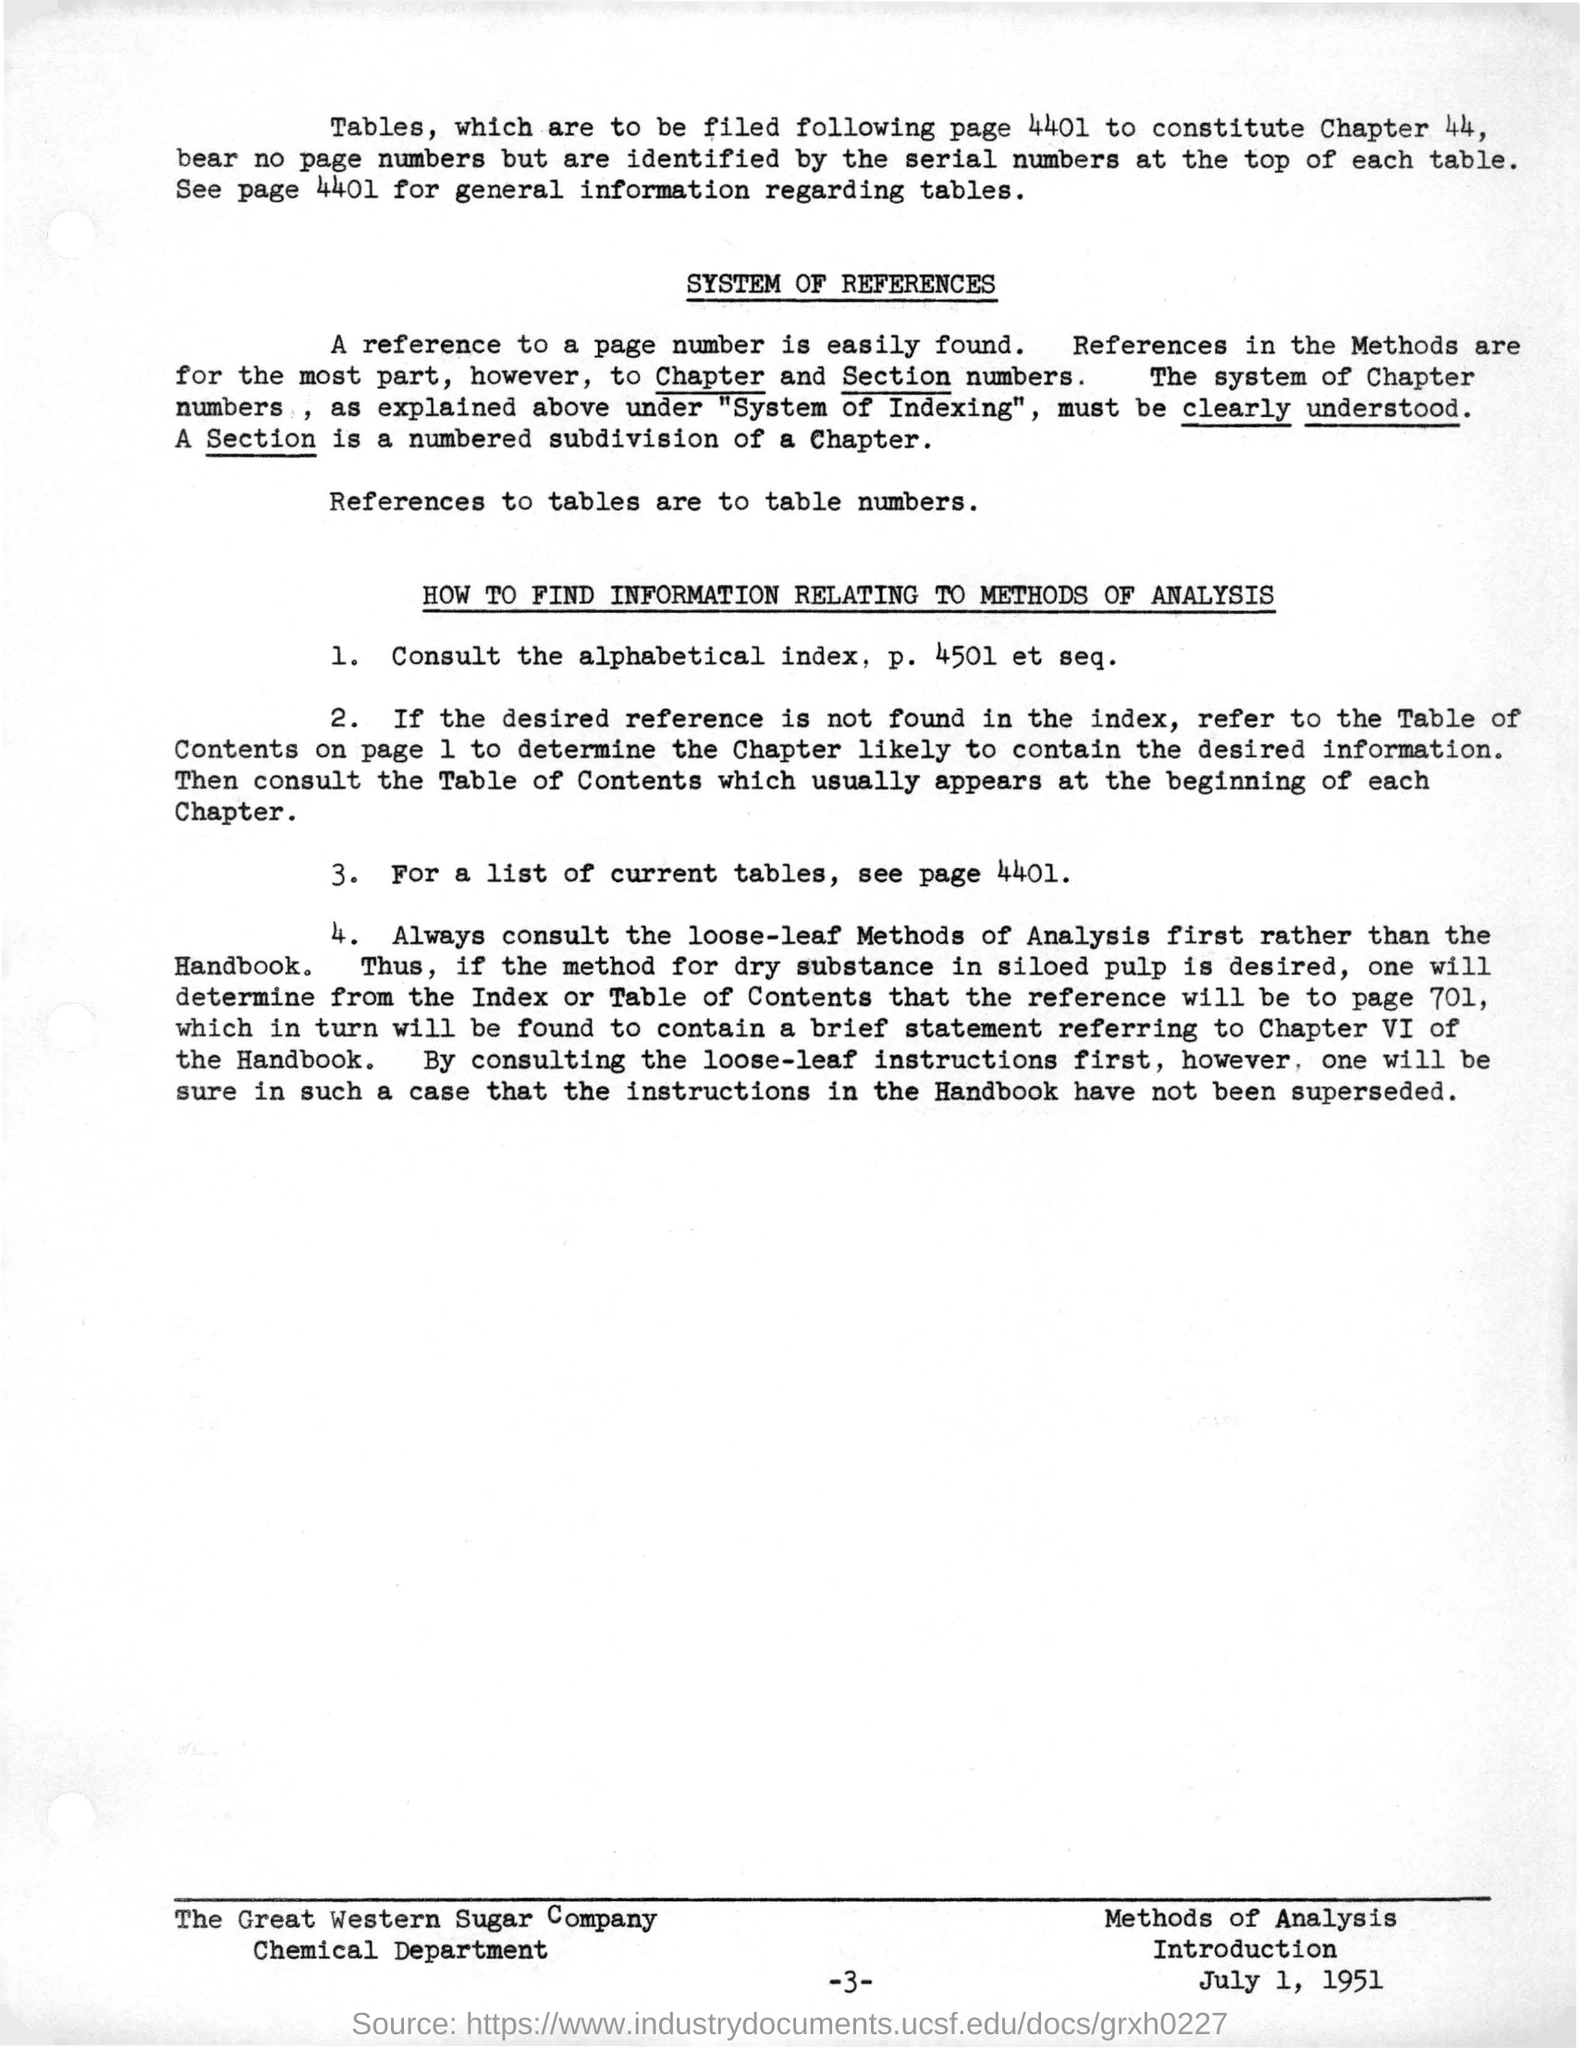See page 4401 for what information regarding tables
Offer a very short reply. For a list of current tables, see page 4401. A reference to what is easily found
Your answer should be compact. A page number. Which page has a list of current tables
Provide a succinct answer. Page 4401. What methods are to be consulted first rather than the handbook
Ensure brevity in your answer.  Loose-leaf. 